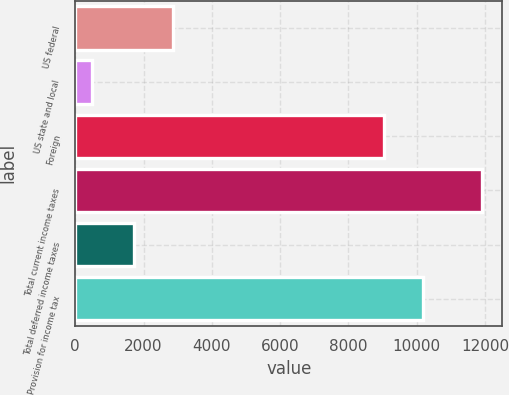Convert chart. <chart><loc_0><loc_0><loc_500><loc_500><bar_chart><fcel>US federal<fcel>US state and local<fcel>Foreign<fcel>Total current income taxes<fcel>Total deferred income taxes<fcel>Provision for income tax<nl><fcel>2859.8<fcel>491<fcel>9028<fcel>11909<fcel>1718<fcel>10191<nl></chart> 